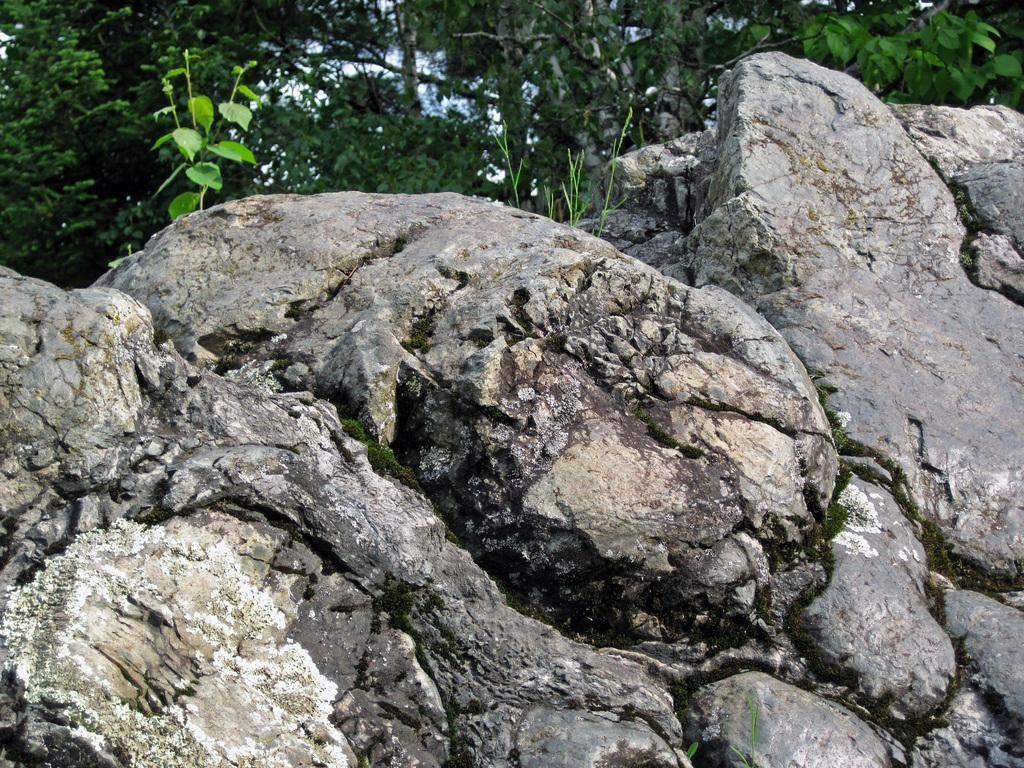What type of natural elements can be seen in the image? There are rocks in the image. What type of vegetation is present in the image? There is a plant in the image. What can be seen in the background of the image? There are trees in the background of the image. What type of religious symbol can be seen in the image? There is no religious symbol present in the image; it features rocks, a plant, and trees. How does the fly affect the acoustics in the image? There is no fly present in the image, so it cannot affect the acoustics. 